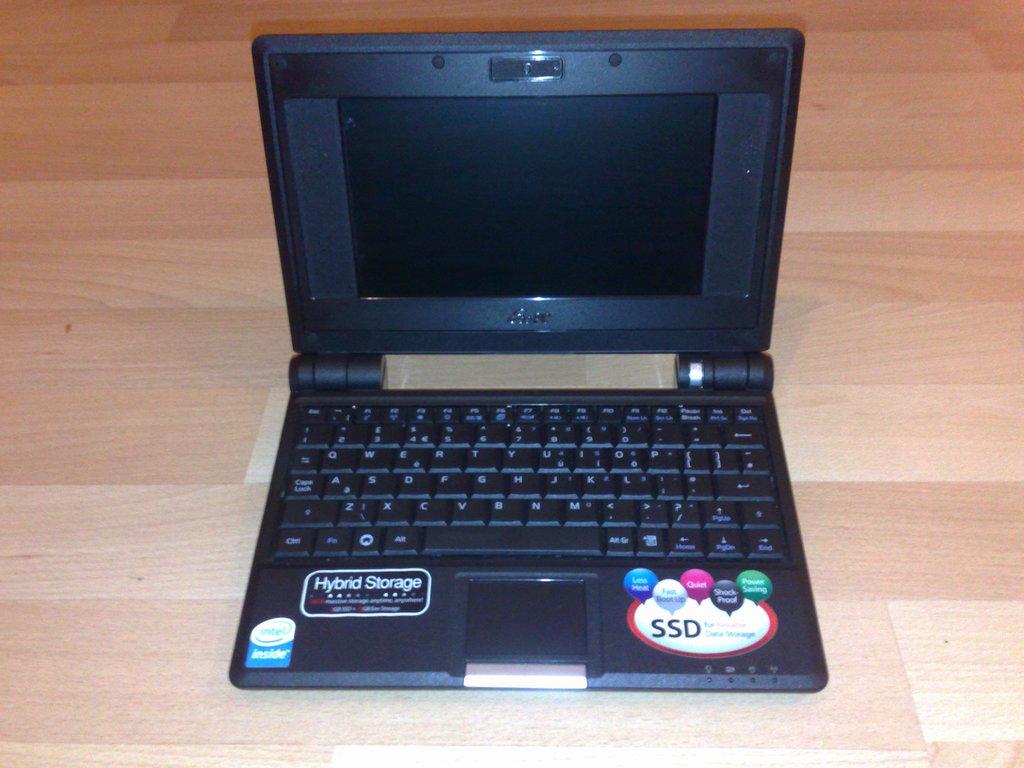What kind of storage is this?
Provide a succinct answer. Hybrid. What type of drive is in the laptop?
Provide a short and direct response. Ssd. 